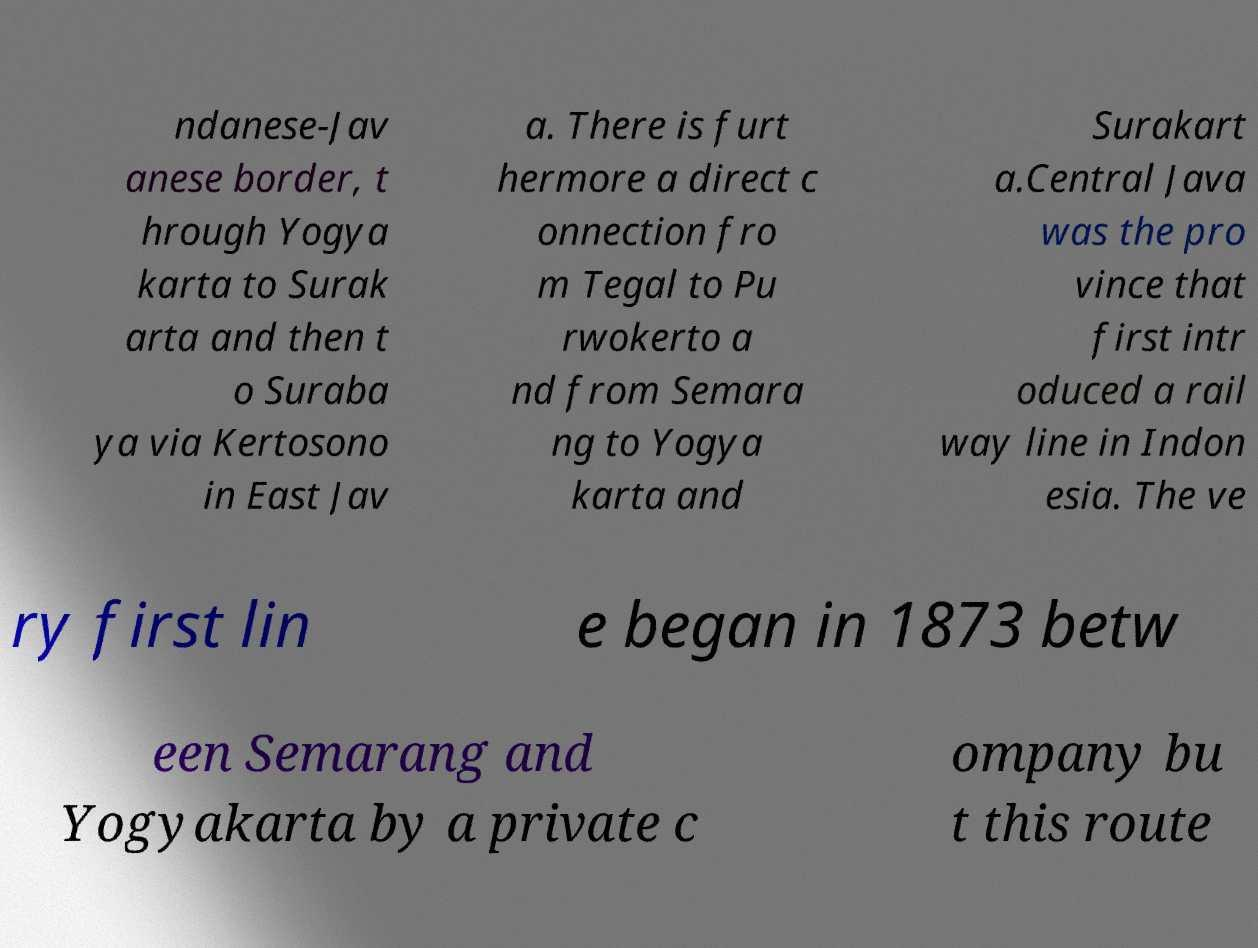Could you assist in decoding the text presented in this image and type it out clearly? ndanese-Jav anese border, t hrough Yogya karta to Surak arta and then t o Suraba ya via Kertosono in East Jav a. There is furt hermore a direct c onnection fro m Tegal to Pu rwokerto a nd from Semara ng to Yogya karta and Surakart a.Central Java was the pro vince that first intr oduced a rail way line in Indon esia. The ve ry first lin e began in 1873 betw een Semarang and Yogyakarta by a private c ompany bu t this route 